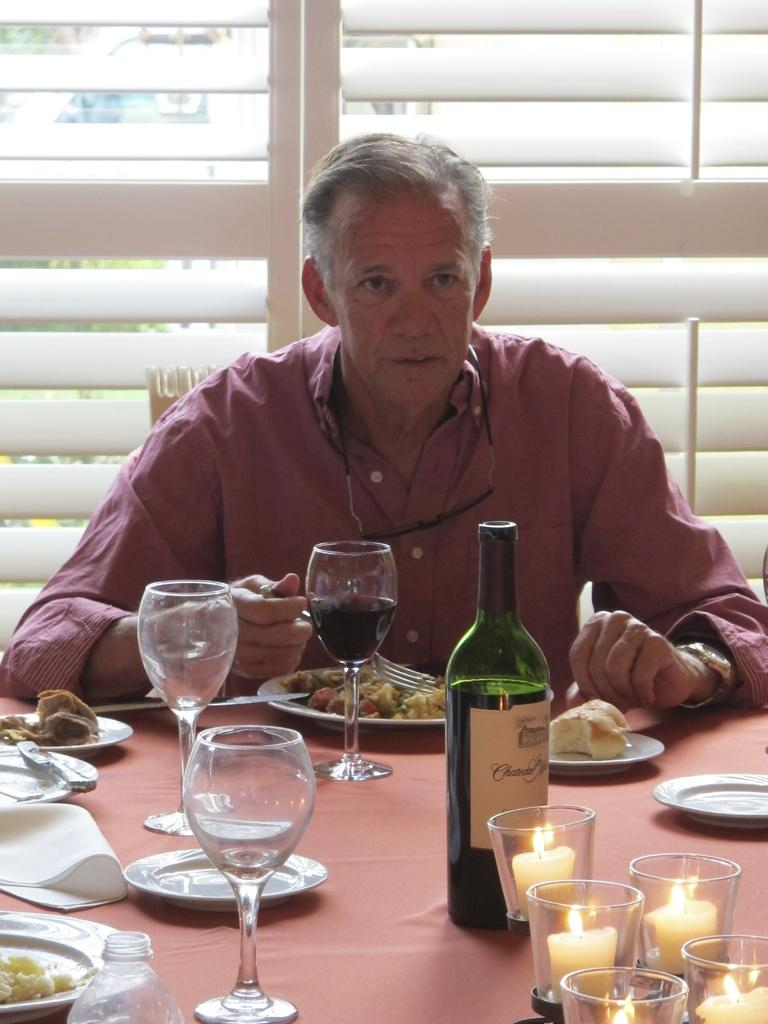What is the man in the image doing? The man is sitting on a chair. What is the man holding in the image? The man is holding a fork. What objects can be seen on the table in the image? There is a bottle, glasses, plates, candles, and food on the table. Can you describe the window in the image? There is a window in the image, but no specific details about it are provided. What type of ink can be seen on the man's shirt in the image? There is no ink visible on the man's shirt in the image. 